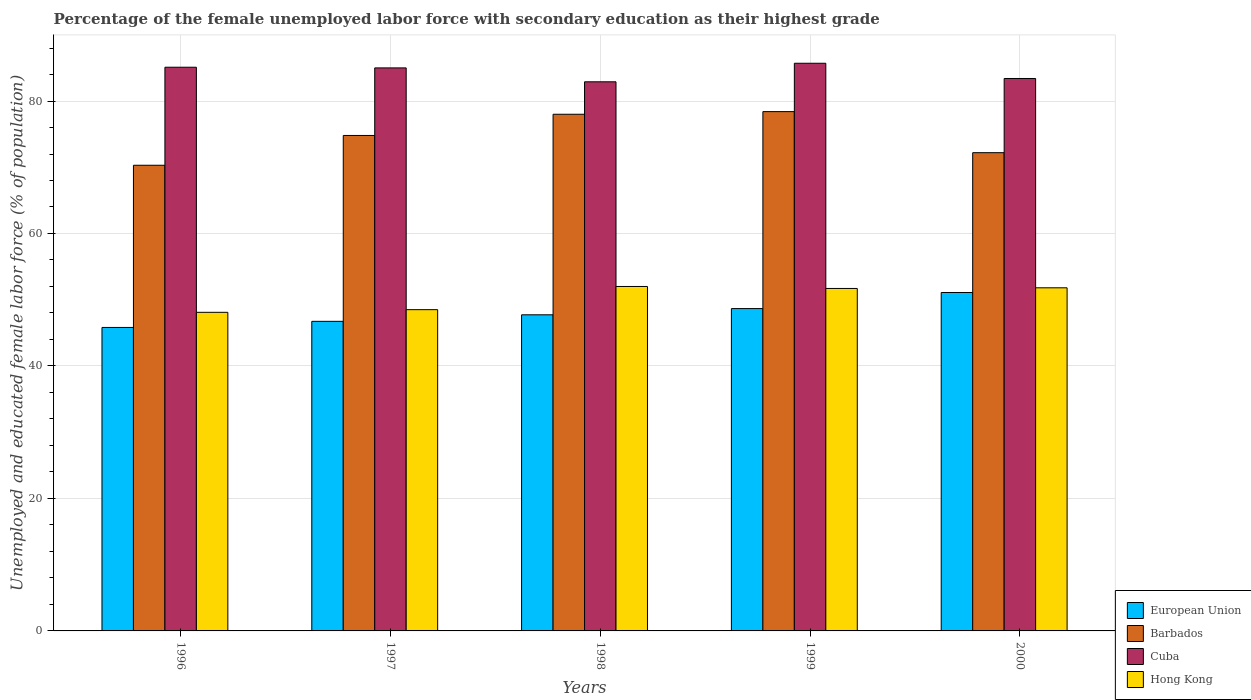How many different coloured bars are there?
Your answer should be compact. 4. How many groups of bars are there?
Give a very brief answer. 5. Are the number of bars per tick equal to the number of legend labels?
Make the answer very short. Yes. Are the number of bars on each tick of the X-axis equal?
Ensure brevity in your answer.  Yes. How many bars are there on the 3rd tick from the left?
Provide a short and direct response. 4. How many bars are there on the 4th tick from the right?
Make the answer very short. 4. What is the percentage of the unemployed female labor force with secondary education in Cuba in 1998?
Provide a short and direct response. 82.9. Across all years, what is the maximum percentage of the unemployed female labor force with secondary education in Hong Kong?
Provide a short and direct response. 52. Across all years, what is the minimum percentage of the unemployed female labor force with secondary education in Hong Kong?
Offer a very short reply. 48.1. What is the total percentage of the unemployed female labor force with secondary education in European Union in the graph?
Make the answer very short. 240.03. What is the difference between the percentage of the unemployed female labor force with secondary education in Hong Kong in 1998 and that in 1999?
Provide a short and direct response. 0.3. What is the difference between the percentage of the unemployed female labor force with secondary education in Hong Kong in 2000 and the percentage of the unemployed female labor force with secondary education in Cuba in 1998?
Your answer should be compact. -31.1. What is the average percentage of the unemployed female labor force with secondary education in Cuba per year?
Give a very brief answer. 84.42. In the year 1999, what is the difference between the percentage of the unemployed female labor force with secondary education in Hong Kong and percentage of the unemployed female labor force with secondary education in European Union?
Provide a succinct answer. 3.04. In how many years, is the percentage of the unemployed female labor force with secondary education in Cuba greater than 16 %?
Your response must be concise. 5. What is the ratio of the percentage of the unemployed female labor force with secondary education in European Union in 1997 to that in 2000?
Offer a terse response. 0.91. Is the percentage of the unemployed female labor force with secondary education in Barbados in 1996 less than that in 1997?
Provide a succinct answer. Yes. Is the difference between the percentage of the unemployed female labor force with secondary education in Hong Kong in 1997 and 1998 greater than the difference between the percentage of the unemployed female labor force with secondary education in European Union in 1997 and 1998?
Your answer should be very brief. No. What is the difference between the highest and the second highest percentage of the unemployed female labor force with secondary education in Cuba?
Provide a short and direct response. 0.6. What is the difference between the highest and the lowest percentage of the unemployed female labor force with secondary education in European Union?
Ensure brevity in your answer.  5.28. What does the 4th bar from the left in 1997 represents?
Your answer should be very brief. Hong Kong. What does the 4th bar from the right in 1997 represents?
Offer a very short reply. European Union. How many years are there in the graph?
Give a very brief answer. 5. Are the values on the major ticks of Y-axis written in scientific E-notation?
Offer a terse response. No. Does the graph contain grids?
Your answer should be compact. Yes. How many legend labels are there?
Offer a terse response. 4. How are the legend labels stacked?
Offer a terse response. Vertical. What is the title of the graph?
Keep it short and to the point. Percentage of the female unemployed labor force with secondary education as their highest grade. What is the label or title of the X-axis?
Offer a very short reply. Years. What is the label or title of the Y-axis?
Keep it short and to the point. Unemployed and educated female labor force (% of population). What is the Unemployed and educated female labor force (% of population) in European Union in 1996?
Provide a succinct answer. 45.82. What is the Unemployed and educated female labor force (% of population) in Barbados in 1996?
Your response must be concise. 70.3. What is the Unemployed and educated female labor force (% of population) of Cuba in 1996?
Your answer should be compact. 85.1. What is the Unemployed and educated female labor force (% of population) in Hong Kong in 1996?
Your response must be concise. 48.1. What is the Unemployed and educated female labor force (% of population) of European Union in 1997?
Keep it short and to the point. 46.74. What is the Unemployed and educated female labor force (% of population) of Barbados in 1997?
Offer a very short reply. 74.8. What is the Unemployed and educated female labor force (% of population) of Cuba in 1997?
Provide a succinct answer. 85. What is the Unemployed and educated female labor force (% of population) of Hong Kong in 1997?
Your response must be concise. 48.5. What is the Unemployed and educated female labor force (% of population) of European Union in 1998?
Your answer should be compact. 47.72. What is the Unemployed and educated female labor force (% of population) of Cuba in 1998?
Keep it short and to the point. 82.9. What is the Unemployed and educated female labor force (% of population) of Hong Kong in 1998?
Keep it short and to the point. 52. What is the Unemployed and educated female labor force (% of population) in European Union in 1999?
Your answer should be compact. 48.66. What is the Unemployed and educated female labor force (% of population) in Barbados in 1999?
Provide a short and direct response. 78.4. What is the Unemployed and educated female labor force (% of population) of Cuba in 1999?
Offer a terse response. 85.7. What is the Unemployed and educated female labor force (% of population) in Hong Kong in 1999?
Keep it short and to the point. 51.7. What is the Unemployed and educated female labor force (% of population) of European Union in 2000?
Your response must be concise. 51.09. What is the Unemployed and educated female labor force (% of population) in Barbados in 2000?
Ensure brevity in your answer.  72.2. What is the Unemployed and educated female labor force (% of population) in Cuba in 2000?
Offer a very short reply. 83.4. What is the Unemployed and educated female labor force (% of population) in Hong Kong in 2000?
Your answer should be compact. 51.8. Across all years, what is the maximum Unemployed and educated female labor force (% of population) of European Union?
Your answer should be very brief. 51.09. Across all years, what is the maximum Unemployed and educated female labor force (% of population) of Barbados?
Provide a succinct answer. 78.4. Across all years, what is the maximum Unemployed and educated female labor force (% of population) of Cuba?
Offer a terse response. 85.7. Across all years, what is the maximum Unemployed and educated female labor force (% of population) in Hong Kong?
Give a very brief answer. 52. Across all years, what is the minimum Unemployed and educated female labor force (% of population) of European Union?
Your answer should be very brief. 45.82. Across all years, what is the minimum Unemployed and educated female labor force (% of population) of Barbados?
Give a very brief answer. 70.3. Across all years, what is the minimum Unemployed and educated female labor force (% of population) of Cuba?
Keep it short and to the point. 82.9. Across all years, what is the minimum Unemployed and educated female labor force (% of population) of Hong Kong?
Keep it short and to the point. 48.1. What is the total Unemployed and educated female labor force (% of population) in European Union in the graph?
Ensure brevity in your answer.  240.03. What is the total Unemployed and educated female labor force (% of population) in Barbados in the graph?
Make the answer very short. 373.7. What is the total Unemployed and educated female labor force (% of population) in Cuba in the graph?
Give a very brief answer. 422.1. What is the total Unemployed and educated female labor force (% of population) of Hong Kong in the graph?
Provide a short and direct response. 252.1. What is the difference between the Unemployed and educated female labor force (% of population) in European Union in 1996 and that in 1997?
Give a very brief answer. -0.92. What is the difference between the Unemployed and educated female labor force (% of population) of Cuba in 1996 and that in 1997?
Give a very brief answer. 0.1. What is the difference between the Unemployed and educated female labor force (% of population) in European Union in 1996 and that in 1998?
Your answer should be very brief. -1.91. What is the difference between the Unemployed and educated female labor force (% of population) in Barbados in 1996 and that in 1998?
Give a very brief answer. -7.7. What is the difference between the Unemployed and educated female labor force (% of population) in Cuba in 1996 and that in 1998?
Your answer should be compact. 2.2. What is the difference between the Unemployed and educated female labor force (% of population) of European Union in 1996 and that in 1999?
Offer a terse response. -2.85. What is the difference between the Unemployed and educated female labor force (% of population) of Cuba in 1996 and that in 1999?
Your answer should be compact. -0.6. What is the difference between the Unemployed and educated female labor force (% of population) in Hong Kong in 1996 and that in 1999?
Your response must be concise. -3.6. What is the difference between the Unemployed and educated female labor force (% of population) of European Union in 1996 and that in 2000?
Provide a short and direct response. -5.28. What is the difference between the Unemployed and educated female labor force (% of population) of Hong Kong in 1996 and that in 2000?
Provide a succinct answer. -3.7. What is the difference between the Unemployed and educated female labor force (% of population) in European Union in 1997 and that in 1998?
Offer a terse response. -0.98. What is the difference between the Unemployed and educated female labor force (% of population) of Cuba in 1997 and that in 1998?
Keep it short and to the point. 2.1. What is the difference between the Unemployed and educated female labor force (% of population) in Hong Kong in 1997 and that in 1998?
Provide a succinct answer. -3.5. What is the difference between the Unemployed and educated female labor force (% of population) of European Union in 1997 and that in 1999?
Make the answer very short. -1.92. What is the difference between the Unemployed and educated female labor force (% of population) of Barbados in 1997 and that in 1999?
Give a very brief answer. -3.6. What is the difference between the Unemployed and educated female labor force (% of population) of Cuba in 1997 and that in 1999?
Ensure brevity in your answer.  -0.7. What is the difference between the Unemployed and educated female labor force (% of population) in Hong Kong in 1997 and that in 1999?
Your answer should be compact. -3.2. What is the difference between the Unemployed and educated female labor force (% of population) in European Union in 1997 and that in 2000?
Provide a succinct answer. -4.35. What is the difference between the Unemployed and educated female labor force (% of population) of Barbados in 1997 and that in 2000?
Offer a terse response. 2.6. What is the difference between the Unemployed and educated female labor force (% of population) in European Union in 1998 and that in 1999?
Your answer should be compact. -0.94. What is the difference between the Unemployed and educated female labor force (% of population) in Barbados in 1998 and that in 1999?
Make the answer very short. -0.4. What is the difference between the Unemployed and educated female labor force (% of population) in European Union in 1998 and that in 2000?
Your answer should be compact. -3.37. What is the difference between the Unemployed and educated female labor force (% of population) in Barbados in 1998 and that in 2000?
Keep it short and to the point. 5.8. What is the difference between the Unemployed and educated female labor force (% of population) in European Union in 1999 and that in 2000?
Your answer should be compact. -2.43. What is the difference between the Unemployed and educated female labor force (% of population) in Cuba in 1999 and that in 2000?
Provide a short and direct response. 2.3. What is the difference between the Unemployed and educated female labor force (% of population) in Hong Kong in 1999 and that in 2000?
Provide a short and direct response. -0.1. What is the difference between the Unemployed and educated female labor force (% of population) of European Union in 1996 and the Unemployed and educated female labor force (% of population) of Barbados in 1997?
Your response must be concise. -28.98. What is the difference between the Unemployed and educated female labor force (% of population) of European Union in 1996 and the Unemployed and educated female labor force (% of population) of Cuba in 1997?
Offer a terse response. -39.18. What is the difference between the Unemployed and educated female labor force (% of population) of European Union in 1996 and the Unemployed and educated female labor force (% of population) of Hong Kong in 1997?
Keep it short and to the point. -2.68. What is the difference between the Unemployed and educated female labor force (% of population) of Barbados in 1996 and the Unemployed and educated female labor force (% of population) of Cuba in 1997?
Keep it short and to the point. -14.7. What is the difference between the Unemployed and educated female labor force (% of population) in Barbados in 1996 and the Unemployed and educated female labor force (% of population) in Hong Kong in 1997?
Your response must be concise. 21.8. What is the difference between the Unemployed and educated female labor force (% of population) in Cuba in 1996 and the Unemployed and educated female labor force (% of population) in Hong Kong in 1997?
Give a very brief answer. 36.6. What is the difference between the Unemployed and educated female labor force (% of population) of European Union in 1996 and the Unemployed and educated female labor force (% of population) of Barbados in 1998?
Your answer should be compact. -32.18. What is the difference between the Unemployed and educated female labor force (% of population) in European Union in 1996 and the Unemployed and educated female labor force (% of population) in Cuba in 1998?
Your response must be concise. -37.08. What is the difference between the Unemployed and educated female labor force (% of population) in European Union in 1996 and the Unemployed and educated female labor force (% of population) in Hong Kong in 1998?
Your answer should be very brief. -6.18. What is the difference between the Unemployed and educated female labor force (% of population) of Barbados in 1996 and the Unemployed and educated female labor force (% of population) of Cuba in 1998?
Provide a short and direct response. -12.6. What is the difference between the Unemployed and educated female labor force (% of population) in Barbados in 1996 and the Unemployed and educated female labor force (% of population) in Hong Kong in 1998?
Your answer should be very brief. 18.3. What is the difference between the Unemployed and educated female labor force (% of population) in Cuba in 1996 and the Unemployed and educated female labor force (% of population) in Hong Kong in 1998?
Your answer should be very brief. 33.1. What is the difference between the Unemployed and educated female labor force (% of population) of European Union in 1996 and the Unemployed and educated female labor force (% of population) of Barbados in 1999?
Your response must be concise. -32.58. What is the difference between the Unemployed and educated female labor force (% of population) in European Union in 1996 and the Unemployed and educated female labor force (% of population) in Cuba in 1999?
Make the answer very short. -39.88. What is the difference between the Unemployed and educated female labor force (% of population) in European Union in 1996 and the Unemployed and educated female labor force (% of population) in Hong Kong in 1999?
Provide a short and direct response. -5.88. What is the difference between the Unemployed and educated female labor force (% of population) in Barbados in 1996 and the Unemployed and educated female labor force (% of population) in Cuba in 1999?
Provide a succinct answer. -15.4. What is the difference between the Unemployed and educated female labor force (% of population) of Cuba in 1996 and the Unemployed and educated female labor force (% of population) of Hong Kong in 1999?
Make the answer very short. 33.4. What is the difference between the Unemployed and educated female labor force (% of population) in European Union in 1996 and the Unemployed and educated female labor force (% of population) in Barbados in 2000?
Give a very brief answer. -26.38. What is the difference between the Unemployed and educated female labor force (% of population) of European Union in 1996 and the Unemployed and educated female labor force (% of population) of Cuba in 2000?
Your answer should be very brief. -37.58. What is the difference between the Unemployed and educated female labor force (% of population) in European Union in 1996 and the Unemployed and educated female labor force (% of population) in Hong Kong in 2000?
Ensure brevity in your answer.  -5.98. What is the difference between the Unemployed and educated female labor force (% of population) in Barbados in 1996 and the Unemployed and educated female labor force (% of population) in Cuba in 2000?
Offer a terse response. -13.1. What is the difference between the Unemployed and educated female labor force (% of population) in Cuba in 1996 and the Unemployed and educated female labor force (% of population) in Hong Kong in 2000?
Provide a short and direct response. 33.3. What is the difference between the Unemployed and educated female labor force (% of population) of European Union in 1997 and the Unemployed and educated female labor force (% of population) of Barbados in 1998?
Provide a short and direct response. -31.26. What is the difference between the Unemployed and educated female labor force (% of population) of European Union in 1997 and the Unemployed and educated female labor force (% of population) of Cuba in 1998?
Give a very brief answer. -36.16. What is the difference between the Unemployed and educated female labor force (% of population) of European Union in 1997 and the Unemployed and educated female labor force (% of population) of Hong Kong in 1998?
Offer a very short reply. -5.26. What is the difference between the Unemployed and educated female labor force (% of population) of Barbados in 1997 and the Unemployed and educated female labor force (% of population) of Cuba in 1998?
Keep it short and to the point. -8.1. What is the difference between the Unemployed and educated female labor force (% of population) of Barbados in 1997 and the Unemployed and educated female labor force (% of population) of Hong Kong in 1998?
Offer a very short reply. 22.8. What is the difference between the Unemployed and educated female labor force (% of population) in Cuba in 1997 and the Unemployed and educated female labor force (% of population) in Hong Kong in 1998?
Keep it short and to the point. 33. What is the difference between the Unemployed and educated female labor force (% of population) in European Union in 1997 and the Unemployed and educated female labor force (% of population) in Barbados in 1999?
Ensure brevity in your answer.  -31.66. What is the difference between the Unemployed and educated female labor force (% of population) in European Union in 1997 and the Unemployed and educated female labor force (% of population) in Cuba in 1999?
Keep it short and to the point. -38.96. What is the difference between the Unemployed and educated female labor force (% of population) of European Union in 1997 and the Unemployed and educated female labor force (% of population) of Hong Kong in 1999?
Offer a very short reply. -4.96. What is the difference between the Unemployed and educated female labor force (% of population) of Barbados in 1997 and the Unemployed and educated female labor force (% of population) of Cuba in 1999?
Provide a succinct answer. -10.9. What is the difference between the Unemployed and educated female labor force (% of population) of Barbados in 1997 and the Unemployed and educated female labor force (% of population) of Hong Kong in 1999?
Offer a terse response. 23.1. What is the difference between the Unemployed and educated female labor force (% of population) in Cuba in 1997 and the Unemployed and educated female labor force (% of population) in Hong Kong in 1999?
Keep it short and to the point. 33.3. What is the difference between the Unemployed and educated female labor force (% of population) in European Union in 1997 and the Unemployed and educated female labor force (% of population) in Barbados in 2000?
Offer a very short reply. -25.46. What is the difference between the Unemployed and educated female labor force (% of population) of European Union in 1997 and the Unemployed and educated female labor force (% of population) of Cuba in 2000?
Your response must be concise. -36.66. What is the difference between the Unemployed and educated female labor force (% of population) in European Union in 1997 and the Unemployed and educated female labor force (% of population) in Hong Kong in 2000?
Offer a terse response. -5.06. What is the difference between the Unemployed and educated female labor force (% of population) of Barbados in 1997 and the Unemployed and educated female labor force (% of population) of Hong Kong in 2000?
Your answer should be very brief. 23. What is the difference between the Unemployed and educated female labor force (% of population) in Cuba in 1997 and the Unemployed and educated female labor force (% of population) in Hong Kong in 2000?
Make the answer very short. 33.2. What is the difference between the Unemployed and educated female labor force (% of population) of European Union in 1998 and the Unemployed and educated female labor force (% of population) of Barbados in 1999?
Provide a short and direct response. -30.68. What is the difference between the Unemployed and educated female labor force (% of population) in European Union in 1998 and the Unemployed and educated female labor force (% of population) in Cuba in 1999?
Give a very brief answer. -37.98. What is the difference between the Unemployed and educated female labor force (% of population) in European Union in 1998 and the Unemployed and educated female labor force (% of population) in Hong Kong in 1999?
Provide a short and direct response. -3.98. What is the difference between the Unemployed and educated female labor force (% of population) in Barbados in 1998 and the Unemployed and educated female labor force (% of population) in Cuba in 1999?
Provide a succinct answer. -7.7. What is the difference between the Unemployed and educated female labor force (% of population) of Barbados in 1998 and the Unemployed and educated female labor force (% of population) of Hong Kong in 1999?
Your answer should be compact. 26.3. What is the difference between the Unemployed and educated female labor force (% of population) of Cuba in 1998 and the Unemployed and educated female labor force (% of population) of Hong Kong in 1999?
Your answer should be compact. 31.2. What is the difference between the Unemployed and educated female labor force (% of population) of European Union in 1998 and the Unemployed and educated female labor force (% of population) of Barbados in 2000?
Make the answer very short. -24.48. What is the difference between the Unemployed and educated female labor force (% of population) of European Union in 1998 and the Unemployed and educated female labor force (% of population) of Cuba in 2000?
Keep it short and to the point. -35.68. What is the difference between the Unemployed and educated female labor force (% of population) in European Union in 1998 and the Unemployed and educated female labor force (% of population) in Hong Kong in 2000?
Keep it short and to the point. -4.08. What is the difference between the Unemployed and educated female labor force (% of population) of Barbados in 1998 and the Unemployed and educated female labor force (% of population) of Hong Kong in 2000?
Give a very brief answer. 26.2. What is the difference between the Unemployed and educated female labor force (% of population) of Cuba in 1998 and the Unemployed and educated female labor force (% of population) of Hong Kong in 2000?
Ensure brevity in your answer.  31.1. What is the difference between the Unemployed and educated female labor force (% of population) of European Union in 1999 and the Unemployed and educated female labor force (% of population) of Barbados in 2000?
Your answer should be compact. -23.54. What is the difference between the Unemployed and educated female labor force (% of population) in European Union in 1999 and the Unemployed and educated female labor force (% of population) in Cuba in 2000?
Provide a succinct answer. -34.74. What is the difference between the Unemployed and educated female labor force (% of population) of European Union in 1999 and the Unemployed and educated female labor force (% of population) of Hong Kong in 2000?
Your answer should be compact. -3.14. What is the difference between the Unemployed and educated female labor force (% of population) in Barbados in 1999 and the Unemployed and educated female labor force (% of population) in Cuba in 2000?
Provide a short and direct response. -5. What is the difference between the Unemployed and educated female labor force (% of population) of Barbados in 1999 and the Unemployed and educated female labor force (% of population) of Hong Kong in 2000?
Your answer should be compact. 26.6. What is the difference between the Unemployed and educated female labor force (% of population) of Cuba in 1999 and the Unemployed and educated female labor force (% of population) of Hong Kong in 2000?
Your answer should be compact. 33.9. What is the average Unemployed and educated female labor force (% of population) of European Union per year?
Your answer should be compact. 48.01. What is the average Unemployed and educated female labor force (% of population) of Barbados per year?
Offer a very short reply. 74.74. What is the average Unemployed and educated female labor force (% of population) of Cuba per year?
Give a very brief answer. 84.42. What is the average Unemployed and educated female labor force (% of population) of Hong Kong per year?
Your answer should be compact. 50.42. In the year 1996, what is the difference between the Unemployed and educated female labor force (% of population) in European Union and Unemployed and educated female labor force (% of population) in Barbados?
Make the answer very short. -24.48. In the year 1996, what is the difference between the Unemployed and educated female labor force (% of population) of European Union and Unemployed and educated female labor force (% of population) of Cuba?
Keep it short and to the point. -39.28. In the year 1996, what is the difference between the Unemployed and educated female labor force (% of population) in European Union and Unemployed and educated female labor force (% of population) in Hong Kong?
Provide a succinct answer. -2.28. In the year 1996, what is the difference between the Unemployed and educated female labor force (% of population) of Barbados and Unemployed and educated female labor force (% of population) of Cuba?
Ensure brevity in your answer.  -14.8. In the year 1996, what is the difference between the Unemployed and educated female labor force (% of population) of Barbados and Unemployed and educated female labor force (% of population) of Hong Kong?
Ensure brevity in your answer.  22.2. In the year 1996, what is the difference between the Unemployed and educated female labor force (% of population) in Cuba and Unemployed and educated female labor force (% of population) in Hong Kong?
Ensure brevity in your answer.  37. In the year 1997, what is the difference between the Unemployed and educated female labor force (% of population) of European Union and Unemployed and educated female labor force (% of population) of Barbados?
Offer a very short reply. -28.06. In the year 1997, what is the difference between the Unemployed and educated female labor force (% of population) in European Union and Unemployed and educated female labor force (% of population) in Cuba?
Make the answer very short. -38.26. In the year 1997, what is the difference between the Unemployed and educated female labor force (% of population) in European Union and Unemployed and educated female labor force (% of population) in Hong Kong?
Make the answer very short. -1.76. In the year 1997, what is the difference between the Unemployed and educated female labor force (% of population) in Barbados and Unemployed and educated female labor force (% of population) in Hong Kong?
Provide a succinct answer. 26.3. In the year 1997, what is the difference between the Unemployed and educated female labor force (% of population) of Cuba and Unemployed and educated female labor force (% of population) of Hong Kong?
Your answer should be very brief. 36.5. In the year 1998, what is the difference between the Unemployed and educated female labor force (% of population) in European Union and Unemployed and educated female labor force (% of population) in Barbados?
Your answer should be compact. -30.28. In the year 1998, what is the difference between the Unemployed and educated female labor force (% of population) of European Union and Unemployed and educated female labor force (% of population) of Cuba?
Your response must be concise. -35.18. In the year 1998, what is the difference between the Unemployed and educated female labor force (% of population) in European Union and Unemployed and educated female labor force (% of population) in Hong Kong?
Your answer should be very brief. -4.28. In the year 1998, what is the difference between the Unemployed and educated female labor force (% of population) of Barbados and Unemployed and educated female labor force (% of population) of Hong Kong?
Keep it short and to the point. 26. In the year 1998, what is the difference between the Unemployed and educated female labor force (% of population) in Cuba and Unemployed and educated female labor force (% of population) in Hong Kong?
Keep it short and to the point. 30.9. In the year 1999, what is the difference between the Unemployed and educated female labor force (% of population) of European Union and Unemployed and educated female labor force (% of population) of Barbados?
Give a very brief answer. -29.74. In the year 1999, what is the difference between the Unemployed and educated female labor force (% of population) of European Union and Unemployed and educated female labor force (% of population) of Cuba?
Your answer should be very brief. -37.04. In the year 1999, what is the difference between the Unemployed and educated female labor force (% of population) of European Union and Unemployed and educated female labor force (% of population) of Hong Kong?
Offer a very short reply. -3.04. In the year 1999, what is the difference between the Unemployed and educated female labor force (% of population) in Barbados and Unemployed and educated female labor force (% of population) in Hong Kong?
Ensure brevity in your answer.  26.7. In the year 2000, what is the difference between the Unemployed and educated female labor force (% of population) of European Union and Unemployed and educated female labor force (% of population) of Barbados?
Your answer should be compact. -21.11. In the year 2000, what is the difference between the Unemployed and educated female labor force (% of population) in European Union and Unemployed and educated female labor force (% of population) in Cuba?
Your response must be concise. -32.31. In the year 2000, what is the difference between the Unemployed and educated female labor force (% of population) in European Union and Unemployed and educated female labor force (% of population) in Hong Kong?
Make the answer very short. -0.71. In the year 2000, what is the difference between the Unemployed and educated female labor force (% of population) in Barbados and Unemployed and educated female labor force (% of population) in Hong Kong?
Your answer should be very brief. 20.4. In the year 2000, what is the difference between the Unemployed and educated female labor force (% of population) in Cuba and Unemployed and educated female labor force (% of population) in Hong Kong?
Your answer should be very brief. 31.6. What is the ratio of the Unemployed and educated female labor force (% of population) in European Union in 1996 to that in 1997?
Ensure brevity in your answer.  0.98. What is the ratio of the Unemployed and educated female labor force (% of population) of Barbados in 1996 to that in 1997?
Offer a terse response. 0.94. What is the ratio of the Unemployed and educated female labor force (% of population) in European Union in 1996 to that in 1998?
Make the answer very short. 0.96. What is the ratio of the Unemployed and educated female labor force (% of population) in Barbados in 1996 to that in 1998?
Your answer should be compact. 0.9. What is the ratio of the Unemployed and educated female labor force (% of population) of Cuba in 1996 to that in 1998?
Ensure brevity in your answer.  1.03. What is the ratio of the Unemployed and educated female labor force (% of population) in Hong Kong in 1996 to that in 1998?
Offer a very short reply. 0.93. What is the ratio of the Unemployed and educated female labor force (% of population) in European Union in 1996 to that in 1999?
Offer a very short reply. 0.94. What is the ratio of the Unemployed and educated female labor force (% of population) of Barbados in 1996 to that in 1999?
Offer a terse response. 0.9. What is the ratio of the Unemployed and educated female labor force (% of population) in Hong Kong in 1996 to that in 1999?
Your answer should be very brief. 0.93. What is the ratio of the Unemployed and educated female labor force (% of population) of European Union in 1996 to that in 2000?
Offer a very short reply. 0.9. What is the ratio of the Unemployed and educated female labor force (% of population) in Barbados in 1996 to that in 2000?
Offer a very short reply. 0.97. What is the ratio of the Unemployed and educated female labor force (% of population) of Cuba in 1996 to that in 2000?
Your response must be concise. 1.02. What is the ratio of the Unemployed and educated female labor force (% of population) of European Union in 1997 to that in 1998?
Your answer should be compact. 0.98. What is the ratio of the Unemployed and educated female labor force (% of population) in Cuba in 1997 to that in 1998?
Your response must be concise. 1.03. What is the ratio of the Unemployed and educated female labor force (% of population) of Hong Kong in 1997 to that in 1998?
Offer a very short reply. 0.93. What is the ratio of the Unemployed and educated female labor force (% of population) in European Union in 1997 to that in 1999?
Ensure brevity in your answer.  0.96. What is the ratio of the Unemployed and educated female labor force (% of population) of Barbados in 1997 to that in 1999?
Offer a terse response. 0.95. What is the ratio of the Unemployed and educated female labor force (% of population) of Hong Kong in 1997 to that in 1999?
Provide a succinct answer. 0.94. What is the ratio of the Unemployed and educated female labor force (% of population) in European Union in 1997 to that in 2000?
Keep it short and to the point. 0.91. What is the ratio of the Unemployed and educated female labor force (% of population) of Barbados in 1997 to that in 2000?
Offer a very short reply. 1.04. What is the ratio of the Unemployed and educated female labor force (% of population) of Cuba in 1997 to that in 2000?
Your response must be concise. 1.02. What is the ratio of the Unemployed and educated female labor force (% of population) of Hong Kong in 1997 to that in 2000?
Provide a succinct answer. 0.94. What is the ratio of the Unemployed and educated female labor force (% of population) in European Union in 1998 to that in 1999?
Offer a terse response. 0.98. What is the ratio of the Unemployed and educated female labor force (% of population) of Cuba in 1998 to that in 1999?
Your response must be concise. 0.97. What is the ratio of the Unemployed and educated female labor force (% of population) of Hong Kong in 1998 to that in 1999?
Ensure brevity in your answer.  1.01. What is the ratio of the Unemployed and educated female labor force (% of population) of European Union in 1998 to that in 2000?
Give a very brief answer. 0.93. What is the ratio of the Unemployed and educated female labor force (% of population) of Barbados in 1998 to that in 2000?
Ensure brevity in your answer.  1.08. What is the ratio of the Unemployed and educated female labor force (% of population) in Hong Kong in 1998 to that in 2000?
Ensure brevity in your answer.  1. What is the ratio of the Unemployed and educated female labor force (% of population) in Barbados in 1999 to that in 2000?
Your answer should be compact. 1.09. What is the ratio of the Unemployed and educated female labor force (% of population) of Cuba in 1999 to that in 2000?
Keep it short and to the point. 1.03. What is the difference between the highest and the second highest Unemployed and educated female labor force (% of population) in European Union?
Your answer should be very brief. 2.43. What is the difference between the highest and the lowest Unemployed and educated female labor force (% of population) in European Union?
Your answer should be compact. 5.28. What is the difference between the highest and the lowest Unemployed and educated female labor force (% of population) in Cuba?
Provide a succinct answer. 2.8. What is the difference between the highest and the lowest Unemployed and educated female labor force (% of population) of Hong Kong?
Provide a succinct answer. 3.9. 